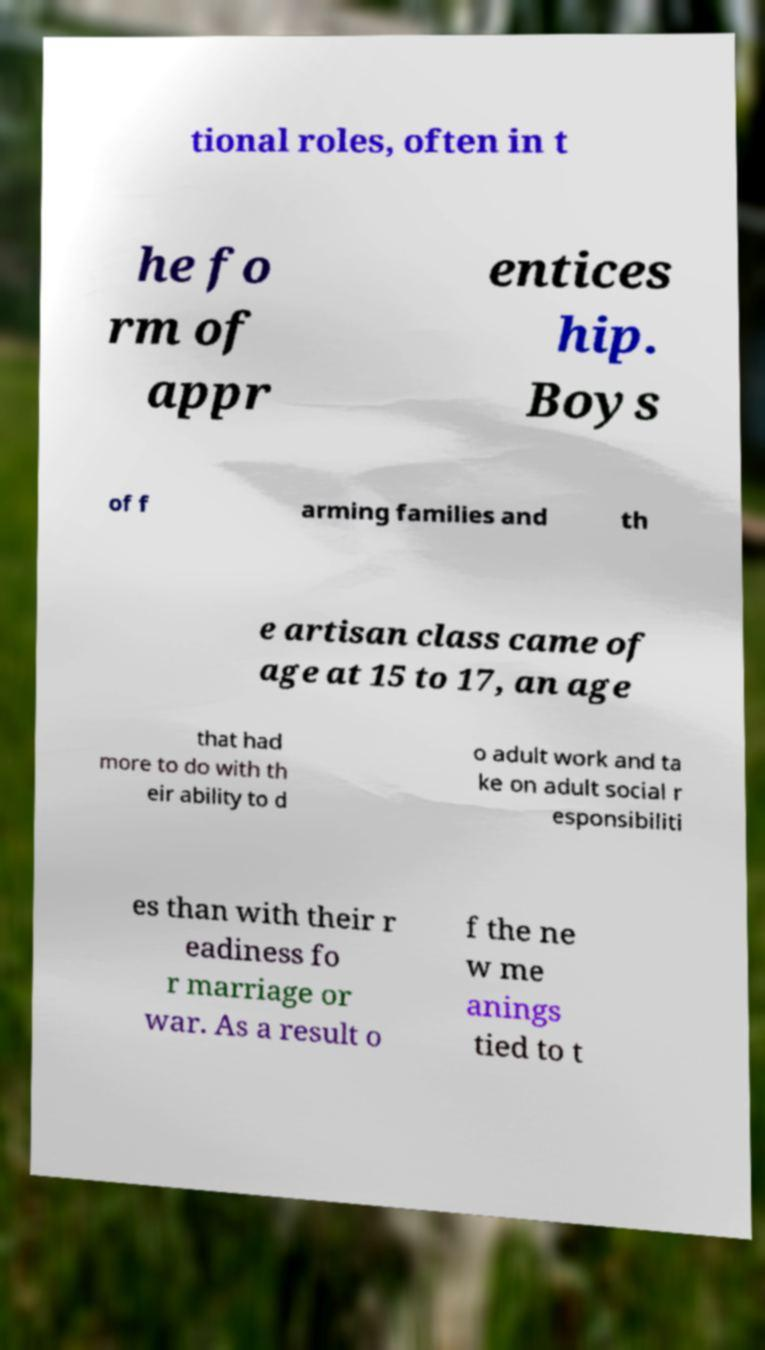Could you extract and type out the text from this image? tional roles, often in t he fo rm of appr entices hip. Boys of f arming families and th e artisan class came of age at 15 to 17, an age that had more to do with th eir ability to d o adult work and ta ke on adult social r esponsibiliti es than with their r eadiness fo r marriage or war. As a result o f the ne w me anings tied to t 